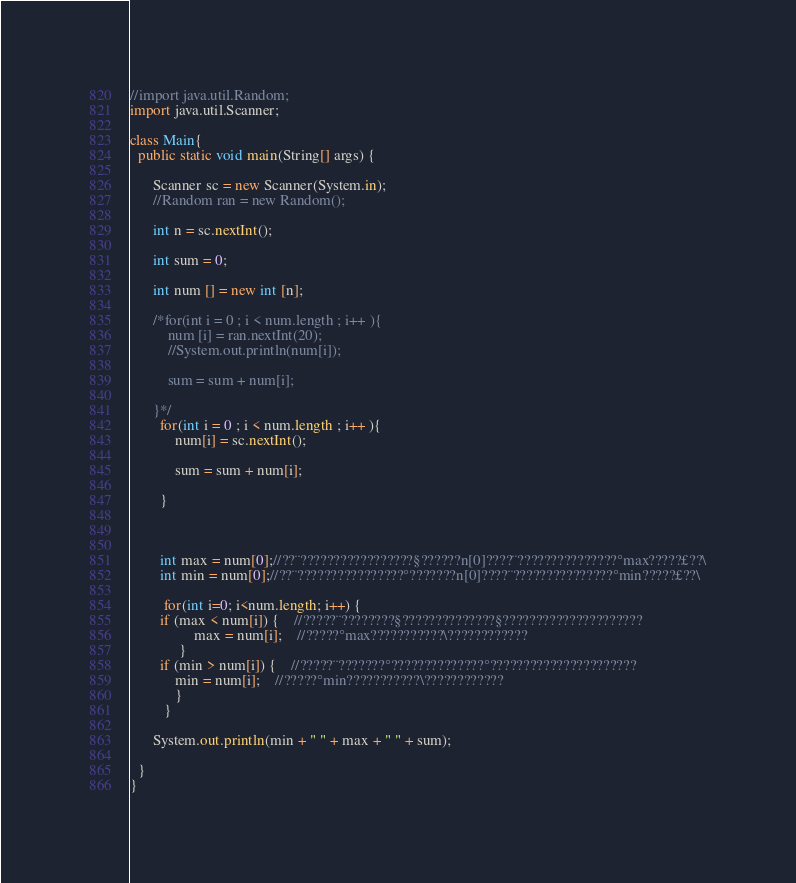<code> <loc_0><loc_0><loc_500><loc_500><_Java_>//import java.util.Random;
import java.util.Scanner;

class Main{
  public static void main(String[] args) {
    
      Scanner sc = new Scanner(System.in);
      //Random ran = new Random();
      
      int n = sc.nextInt();
      
      int sum = 0;
      
      int num [] = new int [n];
      
      /*for(int i = 0 ; i < num.length ; i++ ){
    	  num [i] = ran.nextInt(20);
    	  //System.out.println(num[i]);
    	  
    	  sum = sum + num[i];
    	  
      }*/
      	for(int i = 0 ; i < num.length ; i++ ){
      		num[i] = sc.nextInt();
      		
      		sum = sum + num[i];

      	}
      
      
      
  		int max = num[0];//??¨?????????????????§??????n[0]????¨???????????????°max?????£??\
  		int min = num[0];//??¨????????????????°???????n[0]????¨???????????????°min?????£??\
	
		 for(int i=0; i<num.length; i++) {
		if (max < num[i]) {	//?????¨????????§??????????????§?????????????????????
				 max = num[i];	//?????°max???????????\????????????
			 }
		if (min > num[i]) {	//?????¨???????°??????????????°??????????????????????
			min = num[i];	//?????°min???????????\????????????
			}
		 }
	
      System.out.println(min + " " + max + " " + sum);
	
  }
}</code> 